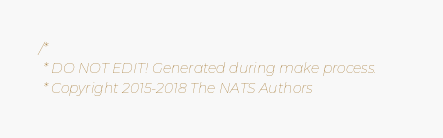Convert code to text. <code><loc_0><loc_0><loc_500><loc_500><_C_>/*
 * DO NOT EDIT! Generated during make process.
 * Copyright 2015-2018 The NATS Authors</code> 